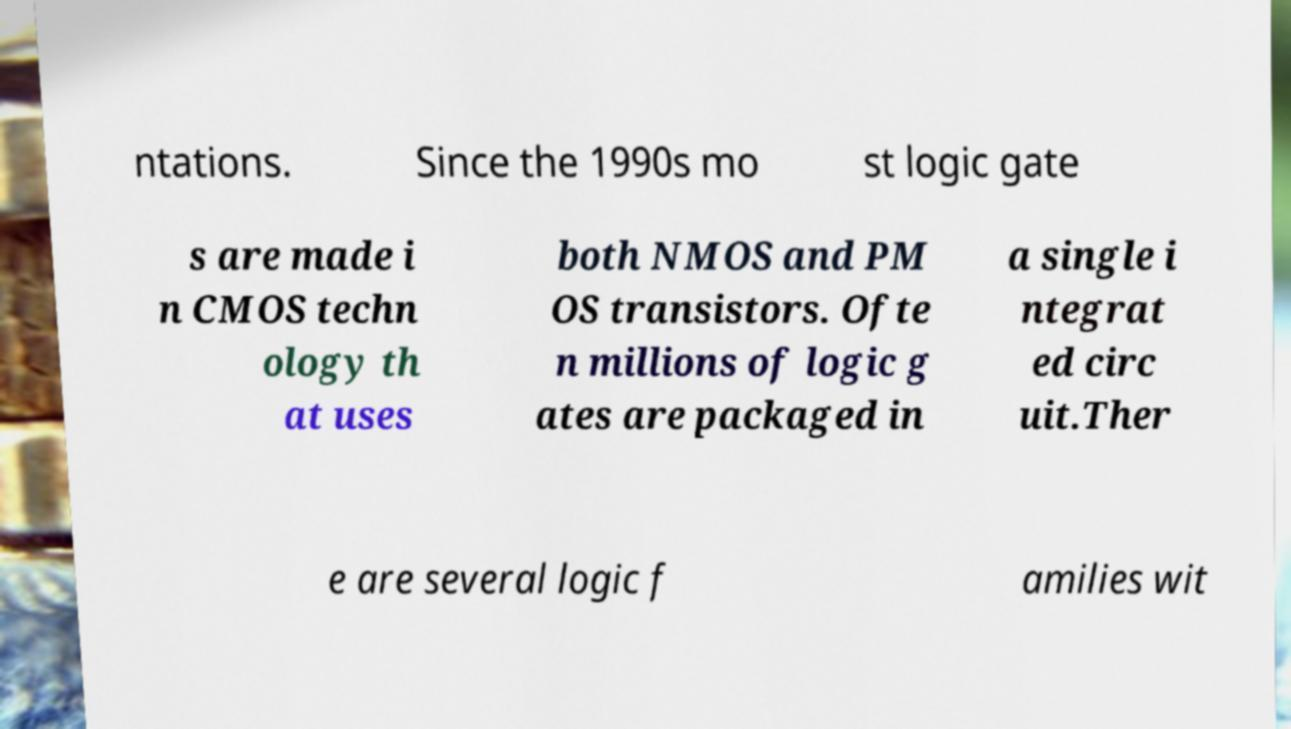There's text embedded in this image that I need extracted. Can you transcribe it verbatim? ntations. Since the 1990s mo st logic gate s are made i n CMOS techn ology th at uses both NMOS and PM OS transistors. Ofte n millions of logic g ates are packaged in a single i ntegrat ed circ uit.Ther e are several logic f amilies wit 